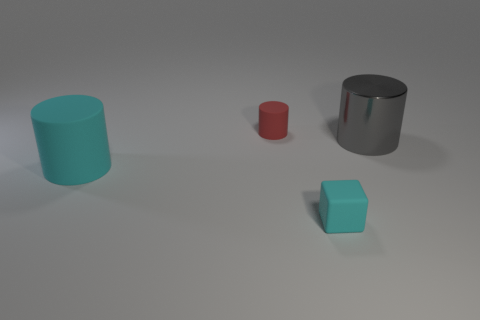There is a big cylinder that is in front of the large metal cylinder; is there a small object behind it?
Offer a very short reply. Yes. What is the material of the tiny object in front of the cyan matte cylinder?
Your response must be concise. Rubber. Is the big cylinder that is behind the cyan cylinder made of the same material as the large cylinder that is left of the tiny cube?
Your answer should be very brief. No. Is the number of metallic things that are on the left side of the cyan cylinder the same as the number of tiny cyan matte blocks that are behind the large shiny thing?
Your answer should be compact. Yes. How many other red cylinders are made of the same material as the red cylinder?
Provide a short and direct response. 0. There is a matte object that is the same color as the tiny rubber cube; what is its shape?
Make the answer very short. Cylinder. What is the size of the rubber cylinder that is in front of the matte cylinder behind the cyan rubber cylinder?
Offer a very short reply. Large. There is a cyan matte object that is behind the small cyan matte block; is it the same shape as the big object that is to the right of the red thing?
Keep it short and to the point. Yes. Is the number of matte blocks that are behind the big cyan rubber cylinder the same as the number of big gray metallic cylinders?
Make the answer very short. No. There is a small rubber thing that is the same shape as the big gray metallic object; what color is it?
Ensure brevity in your answer.  Red. 